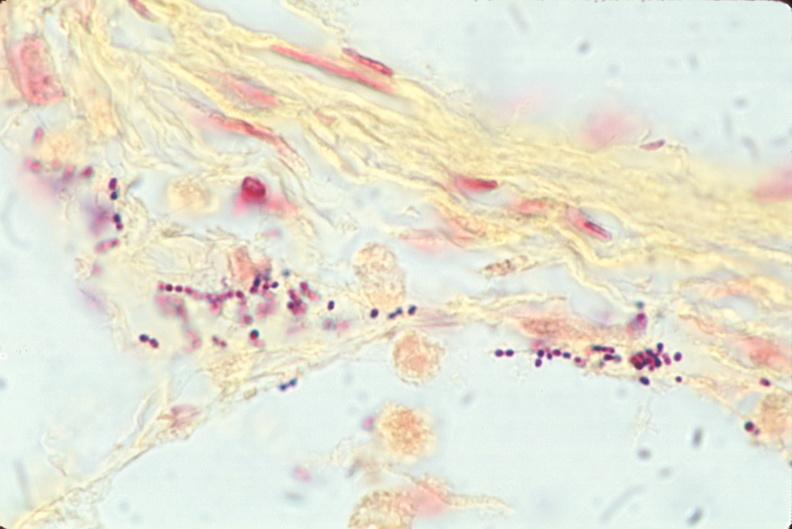what is present?
Answer the question using a single word or phrase. Respiratory 